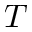<formula> <loc_0><loc_0><loc_500><loc_500>T</formula> 